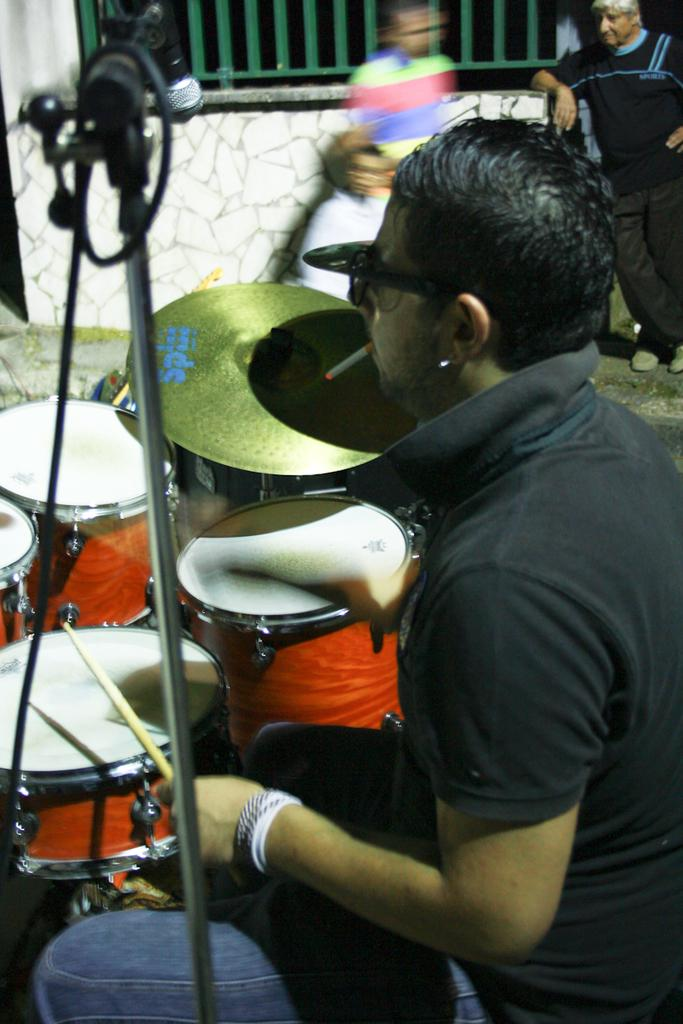What is the person in the image doing? The person is playing a musical instrument. How is the person playing the instrument? The person is using a stick to play the instrument. What is placed in front of the person? There is a microphone in front of the person. Can you describe the people in the background? There are other people standing far from the person playing the instrument. What type of books can be seen on the person's head in the image? There are no books present in the image, and the person is not holding anything on their head. 